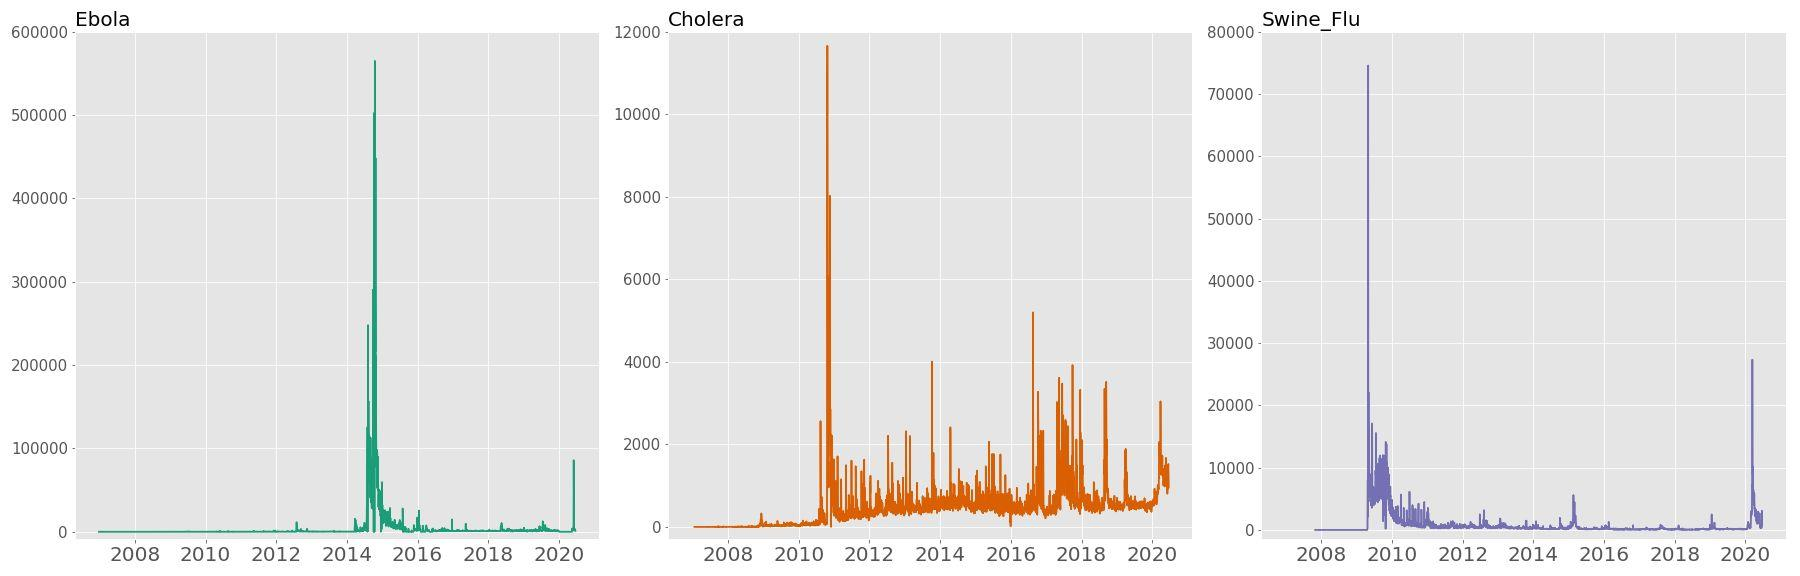Can you explain the patterns we see in the Cholera search frequency over time? Certainly! The Cholera search frequency graph showcases multiple spikes, indicating periodic surges in public interest, likely correlating with outbreaks or newsworthy events related to Cholera. Each spike suggests a time when Cholera was likely at the forefront of public concern, prompting individuals to seek information about the illness, its symptoms, treatment options, or locations affected. 